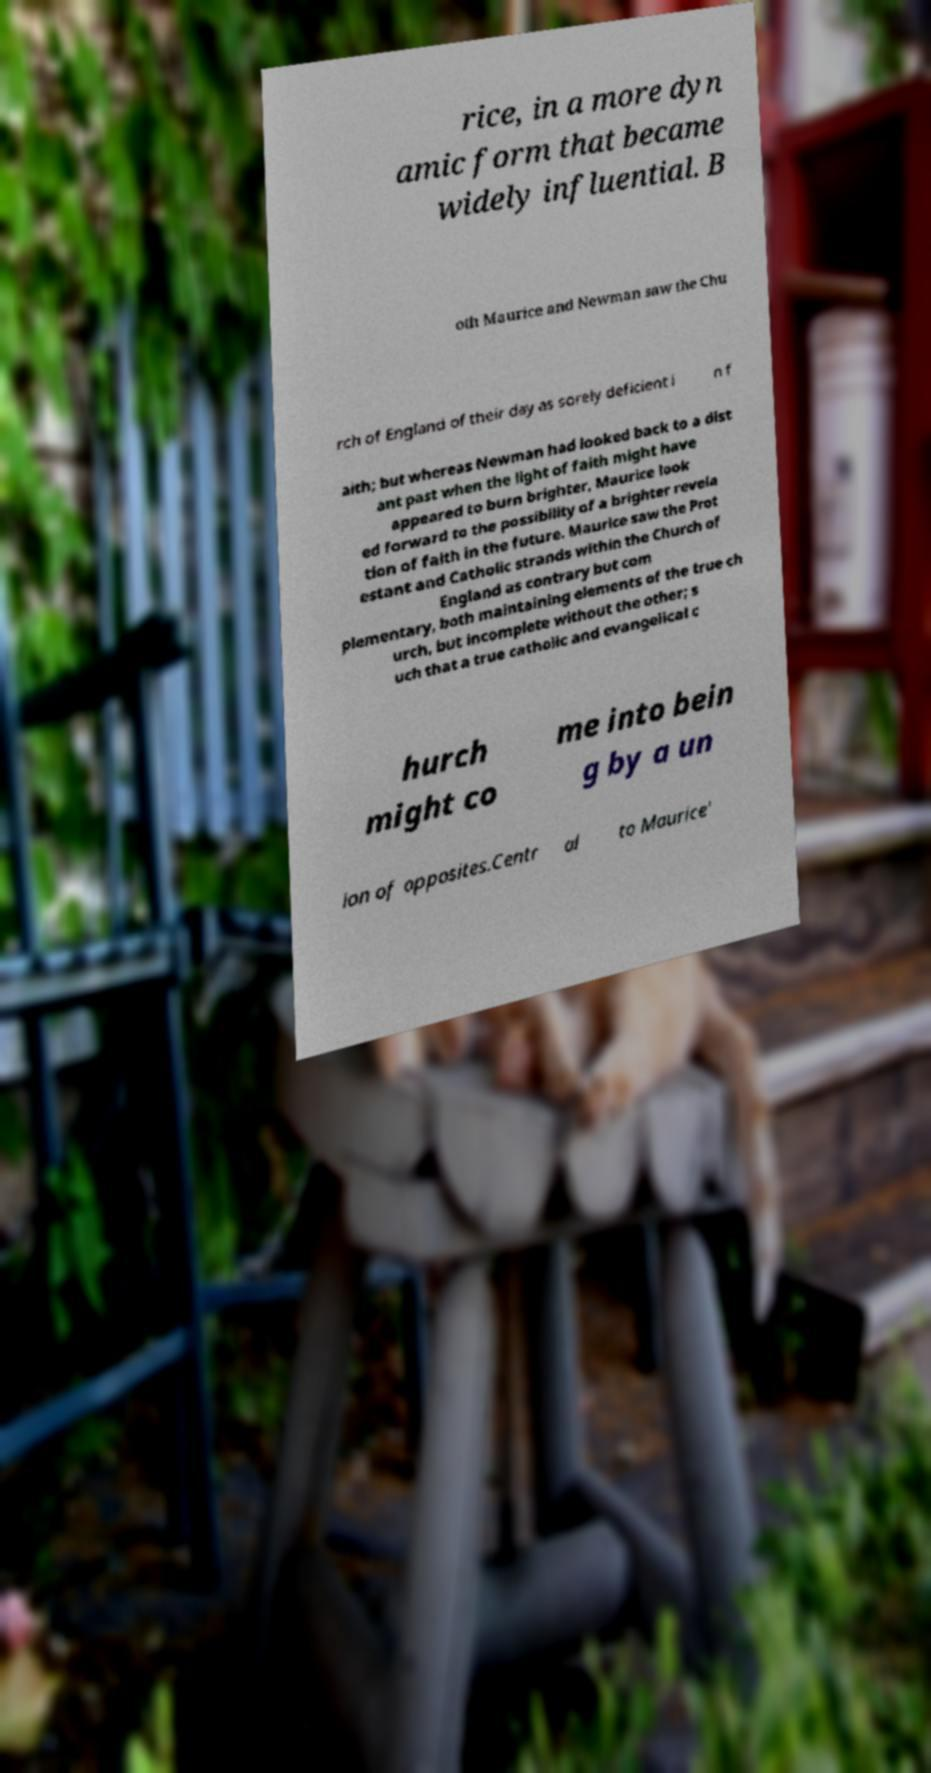Can you read and provide the text displayed in the image?This photo seems to have some interesting text. Can you extract and type it out for me? rice, in a more dyn amic form that became widely influential. B oth Maurice and Newman saw the Chu rch of England of their day as sorely deficient i n f aith; but whereas Newman had looked back to a dist ant past when the light of faith might have appeared to burn brighter, Maurice look ed forward to the possibility of a brighter revela tion of faith in the future. Maurice saw the Prot estant and Catholic strands within the Church of England as contrary but com plementary, both maintaining elements of the true ch urch, but incomplete without the other; s uch that a true catholic and evangelical c hurch might co me into bein g by a un ion of opposites.Centr al to Maurice' 